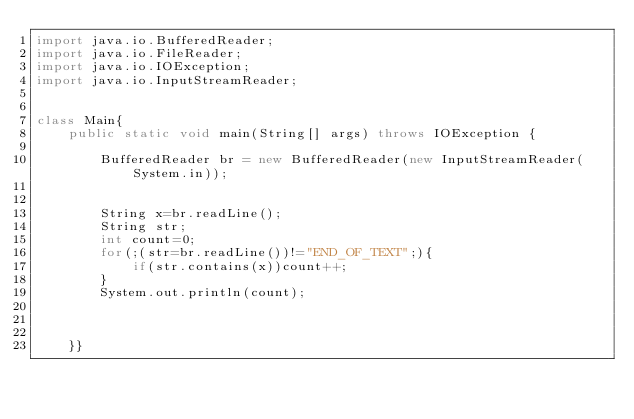<code> <loc_0><loc_0><loc_500><loc_500><_Java_>import java.io.BufferedReader;
import java.io.FileReader;
import java.io.IOException;
import java.io.InputStreamReader;


class Main{
	public static void main(String[] args) throws IOException {

		BufferedReader br = new BufferedReader(new InputStreamReader(System.in));
		
		
		String x=br.readLine();
		String str;
		int count=0;
		for(;(str=br.readLine())!="END_OF_TEXT";){
			if(str.contains(x))count++;
		}
		System.out.println(count);
		
	
	
	}}</code> 